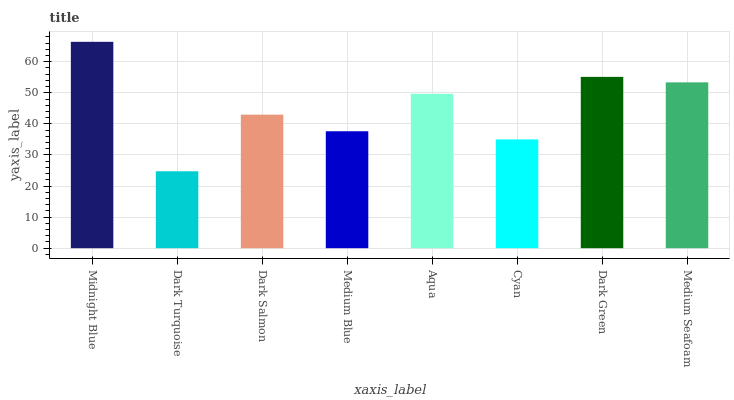Is Dark Turquoise the minimum?
Answer yes or no. Yes. Is Midnight Blue the maximum?
Answer yes or no. Yes. Is Dark Salmon the minimum?
Answer yes or no. No. Is Dark Salmon the maximum?
Answer yes or no. No. Is Dark Salmon greater than Dark Turquoise?
Answer yes or no. Yes. Is Dark Turquoise less than Dark Salmon?
Answer yes or no. Yes. Is Dark Turquoise greater than Dark Salmon?
Answer yes or no. No. Is Dark Salmon less than Dark Turquoise?
Answer yes or no. No. Is Aqua the high median?
Answer yes or no. Yes. Is Dark Salmon the low median?
Answer yes or no. Yes. Is Medium Blue the high median?
Answer yes or no. No. Is Medium Seafoam the low median?
Answer yes or no. No. 